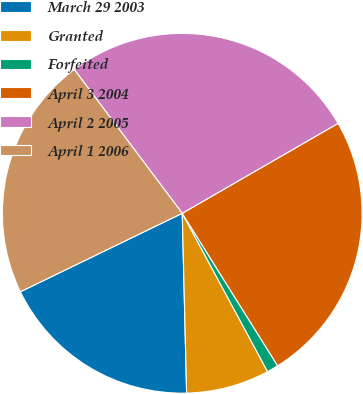Convert chart to OTSL. <chart><loc_0><loc_0><loc_500><loc_500><pie_chart><fcel>March 29 2003<fcel>Granted<fcel>Forfeited<fcel>April 3 2004<fcel>April 2 2005<fcel>April 1 2006<nl><fcel>18.2%<fcel>7.48%<fcel>1.03%<fcel>24.43%<fcel>26.92%<fcel>21.93%<nl></chart> 